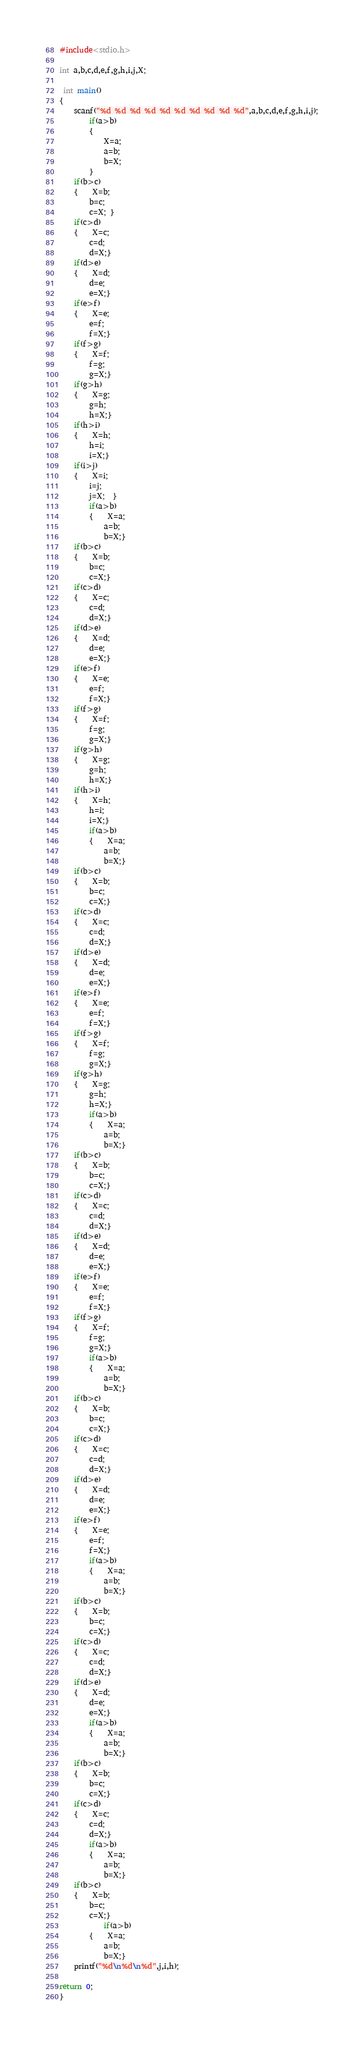<code> <loc_0><loc_0><loc_500><loc_500><_C++_>#include<stdio.h>

int a,b,c,d,e,f,g,h,i,j,X;

 int main()
{
	scanf("%d %d %d %d %d %d %d %d %d %d",a,b,c,d,e,f,g,h,i,j);
		if(a>b)
		{
			X=a;
			a=b;
			b=X;
		}
	if(b>c)
	{	X=b;
		b=c;
		c=X; }
	if(c>d)
	{	X=c;
		c=d;
		d=X;}
	if(d>e)
	{	X=d;
		d=e;
		e=X;}
	if(e>f)
	{	X=e;
		e=f;
		f=X;}
	if(f>g)
	{	X=f;
		f=g;
		g=X;}
	if(g>h)
	{	X=g;
		g=h;
		h=X;}
	if(h>i)
	{	X=h;
		h=i;
		i=X;}
	if(i>j)
	{	X=i;
		i=j;
		j=X;  }
		if(a>b)
		{	X=a;
			a=b;
			b=X;}
	if(b>c)
	{	X=b;
		b=c;
		c=X;}
	if(c>d)
	{	X=c;
		c=d;
		d=X;}
	if(d>e)
	{	X=d;
		d=e;
		e=X;}
	if(e>f)
	{	X=e;
		e=f;
		f=X;}
	if(f>g)
	{	X=f;
		f=g;
		g=X;}
	if(g>h)
	{	X=g;
		g=h;
		h=X;}
	if(h>i)
	{	X=h;
		h=i;
		i=X;}
		if(a>b)
		{	X=a;
			a=b;
			b=X;}
	if(b>c)
	{	X=b;
		b=c;
		c=X;}
	if(c>d)
	{	X=c;
		c=d;
		d=X;}
	if(d>e)
	{	X=d;
		d=e;
		e=X;}
	if(e>f)
	{	X=e;
		e=f;
		f=X;}
	if(f>g)
	{	X=f;
		f=g;
		g=X;}
	if(g>h)
	{	X=g;
		g=h;
		h=X;}
		if(a>b)
		{	X=a;
			a=b;
			b=X;}
	if(b>c)
	{	X=b;
		b=c;
		c=X;}
	if(c>d)
	{	X=c;
		c=d;
		d=X;}
	if(d>e)
	{	X=d;
		d=e;
		e=X;}
	if(e>f)
	{	X=e;
		e=f;
		f=X;}
	if(f>g)
	{	X=f;
		f=g;
		g=X;}
		if(a>b)
		{	X=a;
			a=b;
			b=X;}
	if(b>c)
	{	X=b;
		b=c;
		c=X;}
	if(c>d)
	{	X=c;
		c=d;
		d=X;}
	if(d>e)
	{	X=d;
		d=e;
		e=X;}
	if(e>f)
	{	X=e;
		e=f;
		f=X;}
		if(a>b)
		{	X=a;
			a=b;
			b=X;}
	if(b>c)
	{	X=b;
		b=c;
		c=X;}
	if(c>d)
	{	X=c;
		c=d;
		d=X;}
	if(d>e)
	{	X=d;
		d=e;
		e=X;}
		if(a>b)
		{	X=a;
			a=b;
			b=X;}
	if(b>c)
	{	X=b;
		b=c;
		c=X;}
	if(c>d)
	{	X=c;
		c=d;
		d=X;}
		if(a>b)
		{	X=a;
			a=b;
			b=X;}
	if(b>c)
	{	X=b;
		b=c;
		c=X;}
			if(a>b)
		{	X=a;
			a=b;
			b=X;}
	printf("%d\n%d\n%d",j,i,h);

return 0;
}</code> 